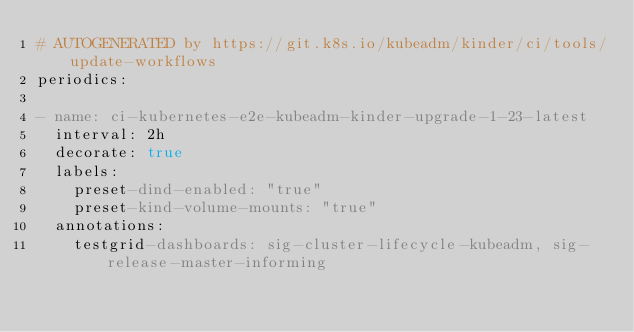Convert code to text. <code><loc_0><loc_0><loc_500><loc_500><_YAML_># AUTOGENERATED by https://git.k8s.io/kubeadm/kinder/ci/tools/update-workflows
periodics:

- name: ci-kubernetes-e2e-kubeadm-kinder-upgrade-1-23-latest
  interval: 2h
  decorate: true
  labels:
    preset-dind-enabled: "true"
    preset-kind-volume-mounts: "true"
  annotations:
    testgrid-dashboards: sig-cluster-lifecycle-kubeadm, sig-release-master-informing</code> 